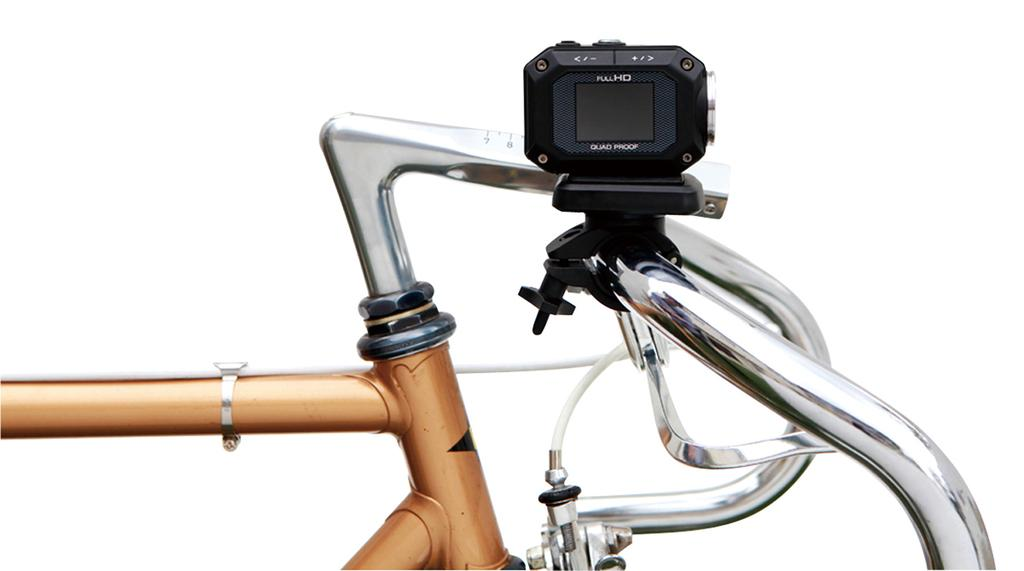What can be seen in the image related to a mode of transportation? There is a part of a bicycle in the image. What additional feature is present on the bicycle? There is a device on the bicycle. What type of cart is visible in the image? There is no cart present in the image; it features a part of a bicycle and a device on it. 